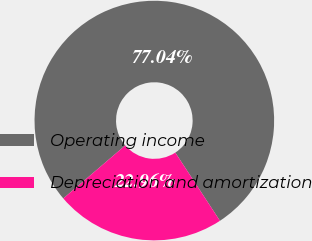Convert chart to OTSL. <chart><loc_0><loc_0><loc_500><loc_500><pie_chart><fcel>Operating income<fcel>Depreciation and amortization<nl><fcel>77.04%<fcel>22.96%<nl></chart> 